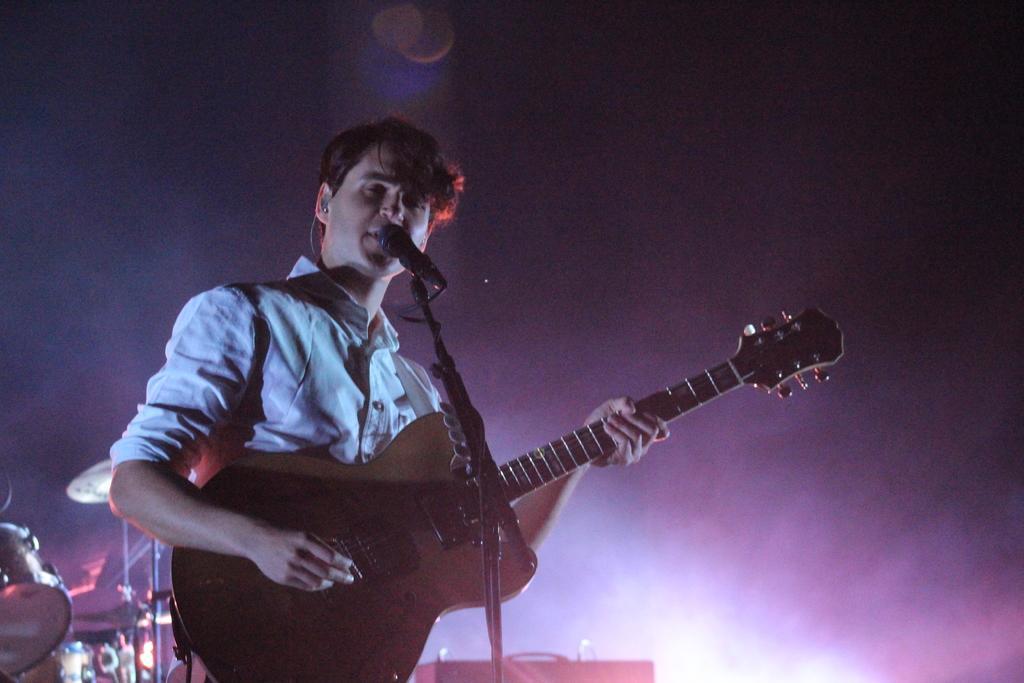How would you summarize this image in a sentence or two? In this image a person is playing guitar along with singing. In front of him there is a mic. Behind him there are drums. 